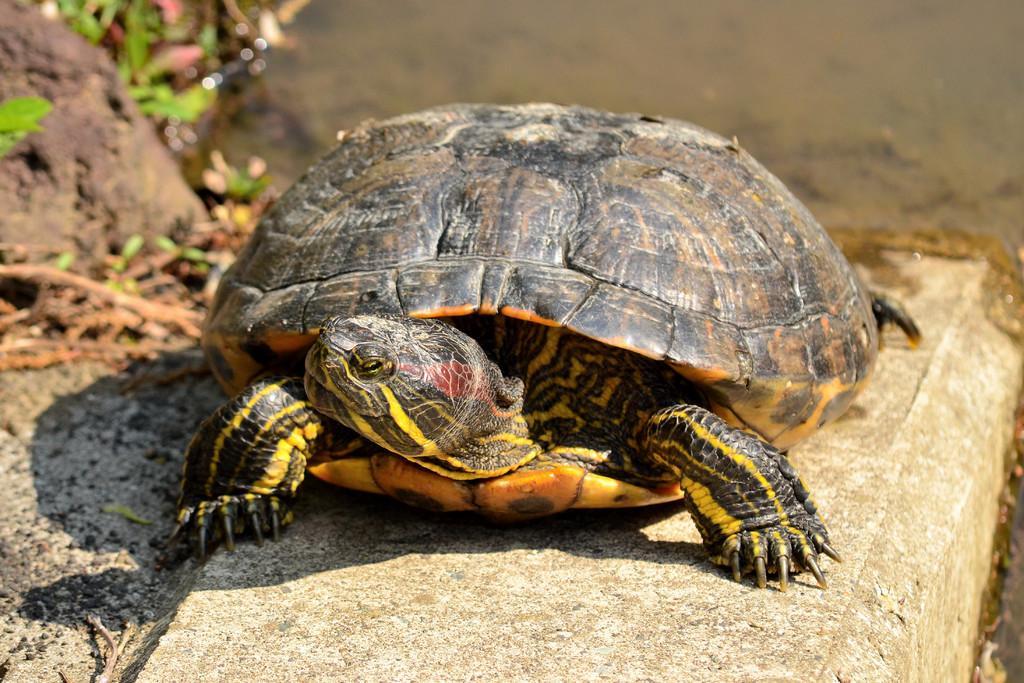In one or two sentences, can you explain what this image depicts? This picture might be taken from outside of the city and it is sunny. In this image, in the middle, we can see a tortoise which is on the land. On the left side, we can also see some stones, plants. In the background, we can also see a water. 